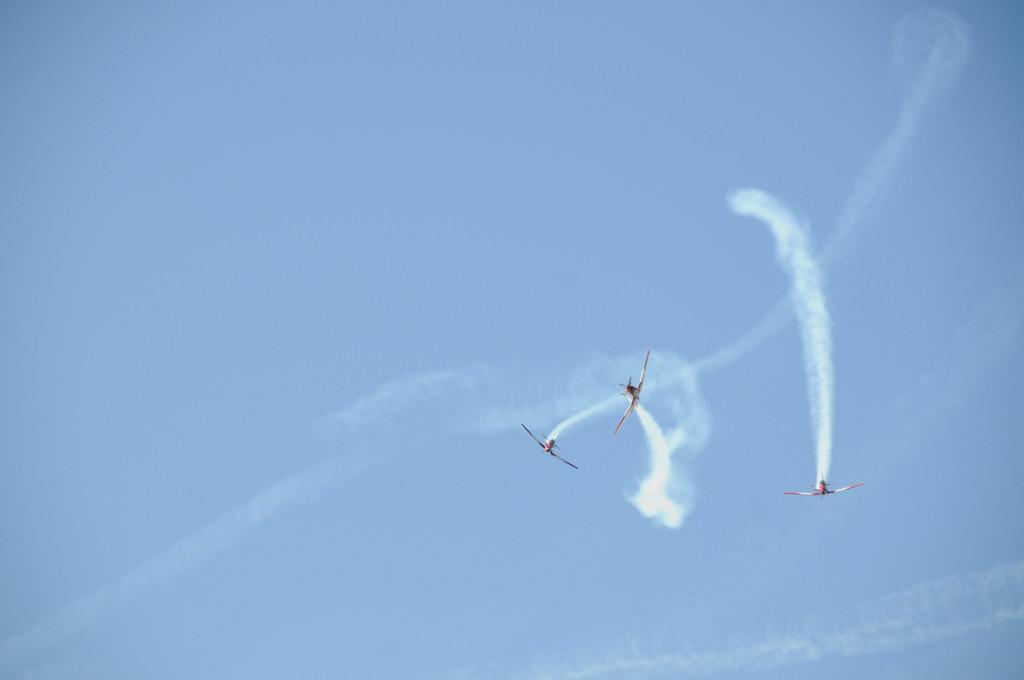Could you give a brief overview of what you see in this image? This picture is clicked outside. On the right we can see there are some objects seems to be the aircraft which are flying in the sky and releasing the smoke. In the background we can see the sky. 